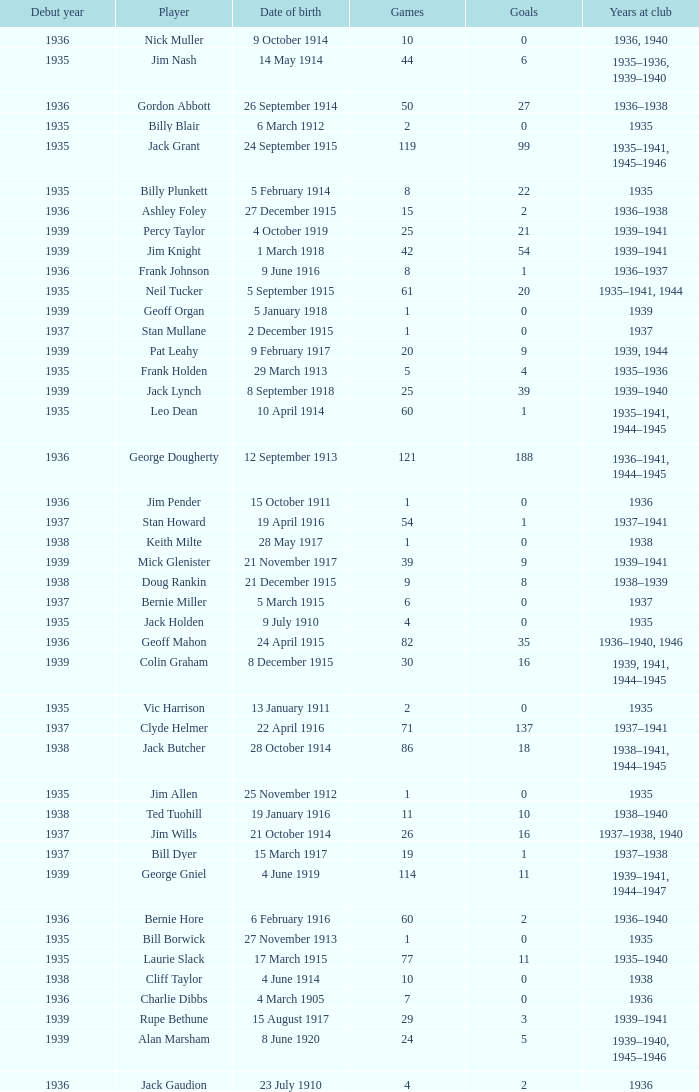What is the years at the club of the player with 2 goals and was born on 23 July 1910? 1936.0. 